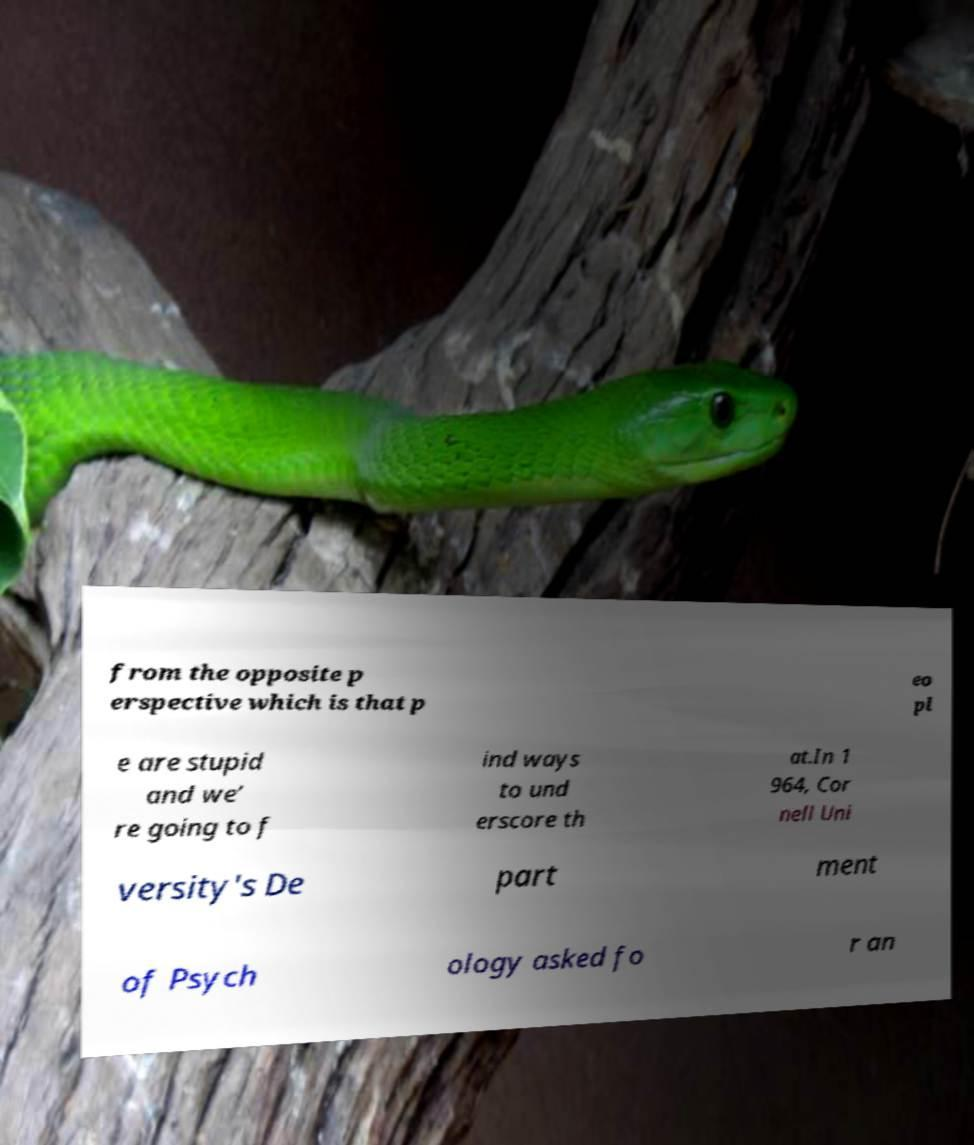Can you accurately transcribe the text from the provided image for me? from the opposite p erspective which is that p eo pl e are stupid and we’ re going to f ind ways to und erscore th at.In 1 964, Cor nell Uni versity's De part ment of Psych ology asked fo r an 